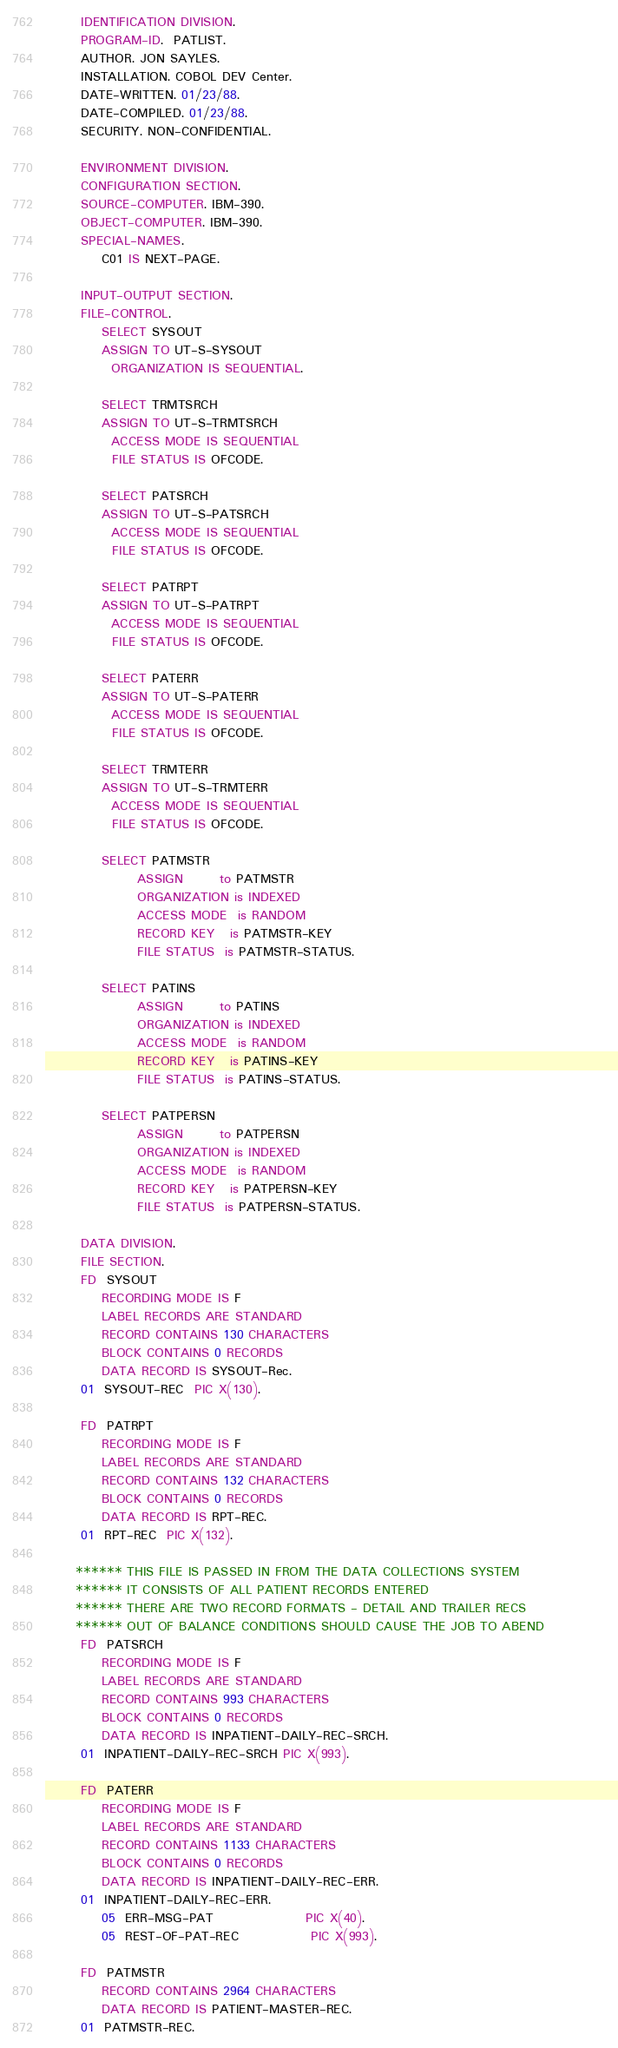<code> <loc_0><loc_0><loc_500><loc_500><_COBOL_>       IDENTIFICATION DIVISION.                                                 
       PROGRAM-ID.  PATLIST.                                                    
       AUTHOR. JON SAYLES.                                                      
       INSTALLATION. COBOL DEV Center.                                          
       DATE-WRITTEN. 01/23/88.                                                  
       DATE-COMPILED. 01/23/88.                                                 
       SECURITY. NON-CONFIDENTIAL.                                              
                                                                                
       ENVIRONMENT DIVISION.                                                    
       CONFIGURATION SECTION.                                                   
       SOURCE-COMPUTER. IBM-390.                                                
       OBJECT-COMPUTER. IBM-390.                                                
       SPECIAL-NAMES.                                                           
           C01 IS NEXT-PAGE.                                                    
                                                                                
       INPUT-OUTPUT SECTION.                                                    
       FILE-CONTROL.                                                            
           SELECT SYSOUT                                                        
           ASSIGN TO UT-S-SYSOUT                                                
             ORGANIZATION IS SEQUENTIAL.                                        
                                                                                
           SELECT TRMTSRCH                                                      
           ASSIGN TO UT-S-TRMTSRCH                                              
             ACCESS MODE IS SEQUENTIAL                                          
             FILE STATUS IS OFCODE.                                             
                                                                                
           SELECT PATSRCH                                                       
           ASSIGN TO UT-S-PATSRCH                                               
             ACCESS MODE IS SEQUENTIAL                                          
             FILE STATUS IS OFCODE.                                             
                                                                                
           SELECT PATRPT                                                        
           ASSIGN TO UT-S-PATRPT                                                
             ACCESS MODE IS SEQUENTIAL                                          
             FILE STATUS IS OFCODE.                                             
                                                                                
           SELECT PATERR                                                        
           ASSIGN TO UT-S-PATERR                                                
             ACCESS MODE IS SEQUENTIAL                                          
             FILE STATUS IS OFCODE.                                             
                                                                                
           SELECT TRMTERR                                                       
           ASSIGN TO UT-S-TRMTERR                                               
             ACCESS MODE IS SEQUENTIAL                                          
             FILE STATUS IS OFCODE.                                             
                                                                                
           SELECT PATMSTR                                                       
                  ASSIGN       to PATMSTR                                       
                  ORGANIZATION is INDEXED                                       
                  ACCESS MODE  is RANDOM                                        
                  RECORD KEY   is PATMSTR-KEY                                   
                  FILE STATUS  is PATMSTR-STATUS.                               
                                                                                
           SELECT PATINS                                                        
                  ASSIGN       to PATINS                                        
                  ORGANIZATION is INDEXED                                       
                  ACCESS MODE  is RANDOM                                        
                  RECORD KEY   is PATINS-KEY                                    
                  FILE STATUS  is PATINS-STATUS.                                
                                                                                
           SELECT PATPERSN                                                      
                  ASSIGN       to PATPERSN                                      
                  ORGANIZATION is INDEXED                                       
                  ACCESS MODE  is RANDOM                                        
                  RECORD KEY   is PATPERSN-KEY                                  
                  FILE STATUS  is PATPERSN-STATUS.                              
                                                                                
       DATA DIVISION.                                                           
       FILE SECTION.                                                            
       FD  SYSOUT                                                               
           RECORDING MODE IS F                                                  
           LABEL RECORDS ARE STANDARD                                           
           RECORD CONTAINS 130 CHARACTERS                                       
           BLOCK CONTAINS 0 RECORDS                                             
           DATA RECORD IS SYSOUT-Rec.                                           
       01  SYSOUT-REC  PIC X(130).                                              
                                                                                
       FD  PATRPT                                                               
           RECORDING MODE IS F                                                  
           LABEL RECORDS ARE STANDARD                                           
           RECORD CONTAINS 132 CHARACTERS                                       
           BLOCK CONTAINS 0 RECORDS                                             
           DATA RECORD IS RPT-REC.                                              
       01  RPT-REC  PIC X(132).                                                 
                                                                                
      ****** THIS FILE IS PASSED IN FROM THE DATA COLLECTIONS SYSTEM            
      ****** IT CONSISTS OF ALL PATIENT RECORDS ENTERED                         
      ****** THERE ARE TWO RECORD FORMATS - DETAIL AND TRAILER RECS             
      ****** OUT OF BALANCE CONDITIONS SHOULD CAUSE THE JOB TO ABEND            
       FD  PATSRCH                                                              
           RECORDING MODE IS F                                                  
           LABEL RECORDS ARE STANDARD                                           
           RECORD CONTAINS 993 CHARACTERS                                       
           BLOCK CONTAINS 0 RECORDS                                             
           DATA RECORD IS INPATIENT-DAILY-REC-SRCH.                             
       01  INPATIENT-DAILY-REC-SRCH PIC X(993).                                 
                                                                                
       FD  PATERR                                                               
           RECORDING MODE IS F                                                  
           LABEL RECORDS ARE STANDARD                                           
           RECORD CONTAINS 1133 CHARACTERS                                      
           BLOCK CONTAINS 0 RECORDS                                             
           DATA RECORD IS INPATIENT-DAILY-REC-ERR.                              
       01  INPATIENT-DAILY-REC-ERR.                                             
           05  ERR-MSG-PAT                  PIC X(40).                          
           05  REST-OF-PAT-REC              PIC X(993).                         
                                                                                
       FD  PATMSTR                                                              
           RECORD CONTAINS 2964 CHARACTERS                                      
           DATA RECORD IS PATIENT-MASTER-REC.                                   
       01  PATMSTR-REC.                                                         </code> 